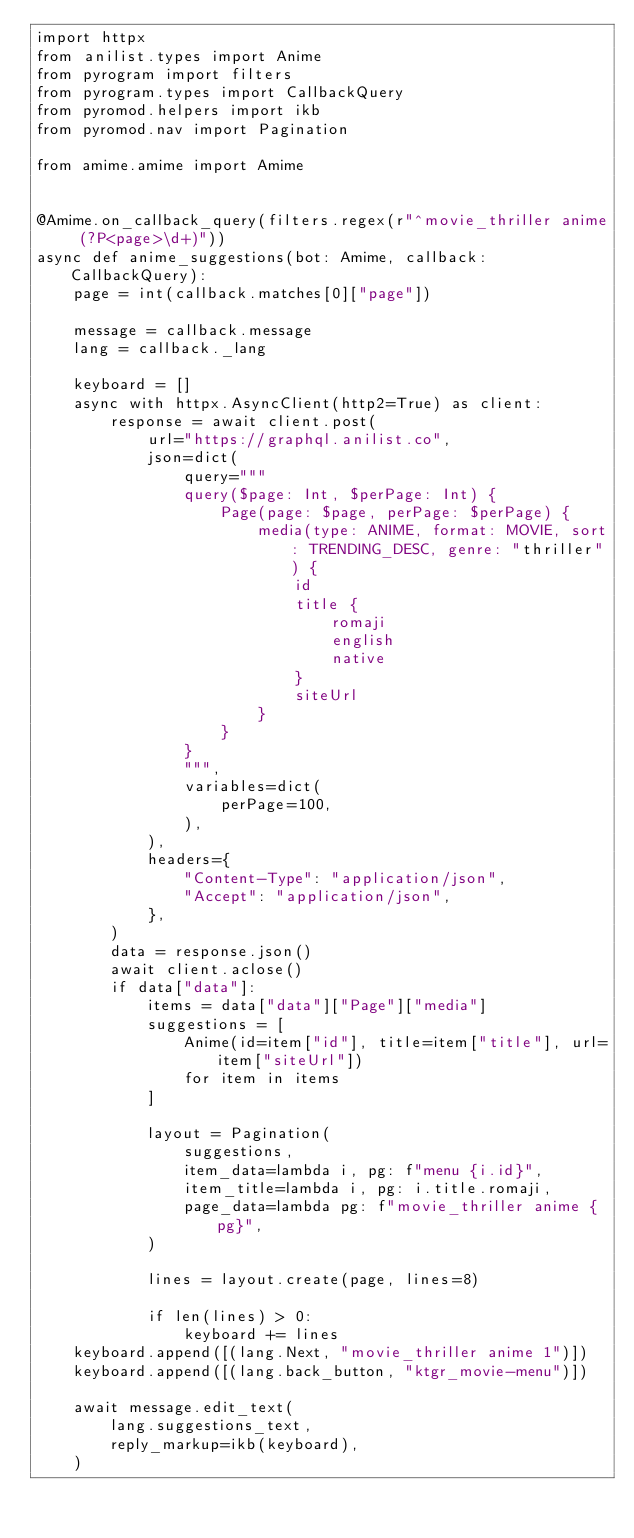<code> <loc_0><loc_0><loc_500><loc_500><_Python_>import httpx
from anilist.types import Anime
from pyrogram import filters
from pyrogram.types import CallbackQuery
from pyromod.helpers import ikb
from pyromod.nav import Pagination

from amime.amime import Amime


@Amime.on_callback_query(filters.regex(r"^movie_thriller anime (?P<page>\d+)"))
async def anime_suggestions(bot: Amime, callback: CallbackQuery):
    page = int(callback.matches[0]["page"])

    message = callback.message
    lang = callback._lang

    keyboard = []
    async with httpx.AsyncClient(http2=True) as client:
        response = await client.post(
            url="https://graphql.anilist.co",
            json=dict(
                query="""
                query($page: Int, $perPage: Int) {
                    Page(page: $page, perPage: $perPage) {
                        media(type: ANIME, format: MOVIE, sort: TRENDING_DESC, genre: "thriller") {
                            id
                            title {
                                romaji
                                english
                                native
                            }
                            siteUrl
                        }
                    }
                }
                """,
                variables=dict(
                    perPage=100,
                ),
            ),
            headers={
                "Content-Type": "application/json",
                "Accept": "application/json",
            },
        )
        data = response.json()
        await client.aclose()
        if data["data"]:
            items = data["data"]["Page"]["media"]
            suggestions = [
                Anime(id=item["id"], title=item["title"], url=item["siteUrl"])
                for item in items
            ]

            layout = Pagination(
                suggestions,
                item_data=lambda i, pg: f"menu {i.id}",
                item_title=lambda i, pg: i.title.romaji,
                page_data=lambda pg: f"movie_thriller anime {pg}",
            )

            lines = layout.create(page, lines=8)

            if len(lines) > 0:
                keyboard += lines
    keyboard.append([(lang.Next, "movie_thriller anime 1")])
    keyboard.append([(lang.back_button, "ktgr_movie-menu")])

    await message.edit_text(
        lang.suggestions_text,
        reply_markup=ikb(keyboard),
    )
</code> 